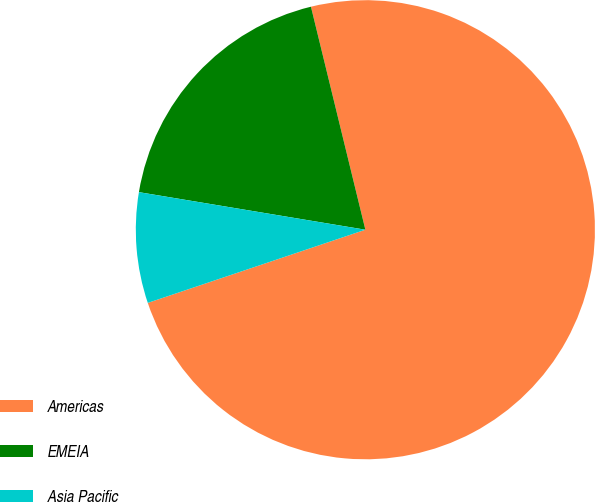Convert chart. <chart><loc_0><loc_0><loc_500><loc_500><pie_chart><fcel>Americas<fcel>EMEIA<fcel>Asia Pacific<nl><fcel>73.64%<fcel>18.57%<fcel>7.78%<nl></chart> 